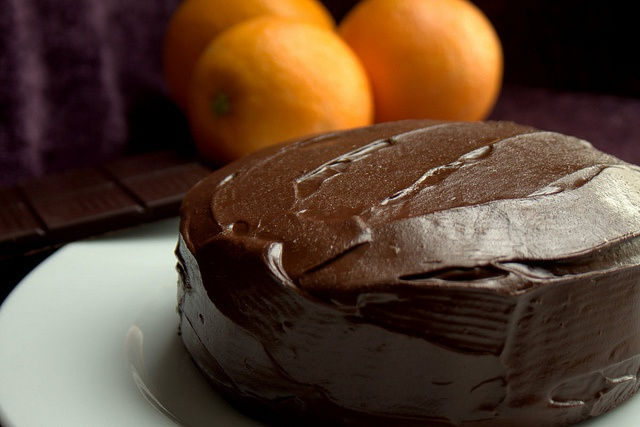Describe the objects in this image and their specific colors. I can see cake in black, maroon, and gray tones and orange in black, brown, maroon, and orange tones in this image. 